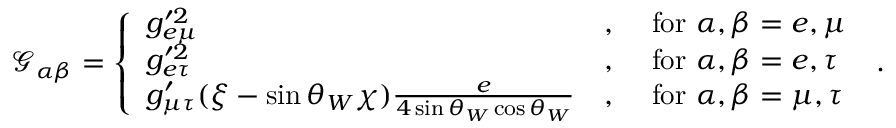<formula> <loc_0><loc_0><loc_500><loc_500>\mathcal { G } _ { \alpha \beta } = \left \{ \begin{array} { l l l } { g _ { e \mu } ^ { \prime 2 } } & { , } & { f o r \alpha , \beta = e , \mu } \\ { g _ { e \tau } ^ { \prime 2 } } & { , } & { f o r \alpha , \beta = e , \tau } \\ { g _ { \mu \tau } ^ { \prime } ( \xi - \sin \theta _ { W } \chi ) \frac { e } { 4 \sin \theta _ { W } \cos \theta _ { W } } } & { , } & { f o r \alpha , \beta = \mu , \tau } \end{array} \, .</formula> 